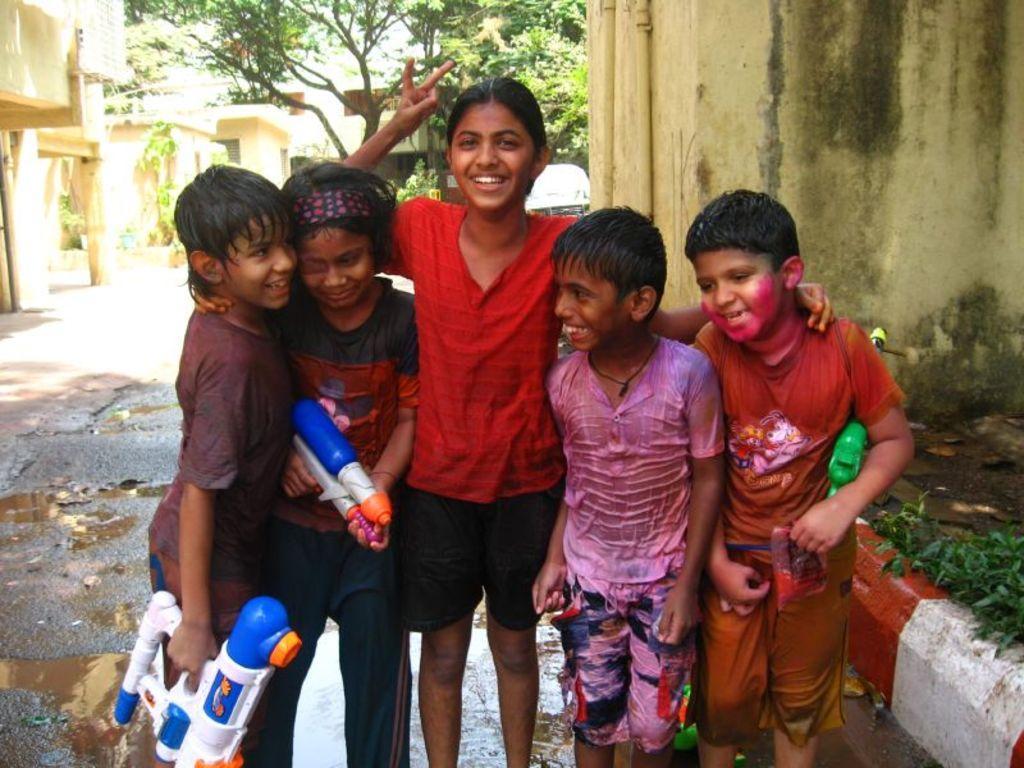Please provide a concise description of this image. In this picture we can see five people and they are smiling and in the background we can see buildings, trees and a vehicle. 